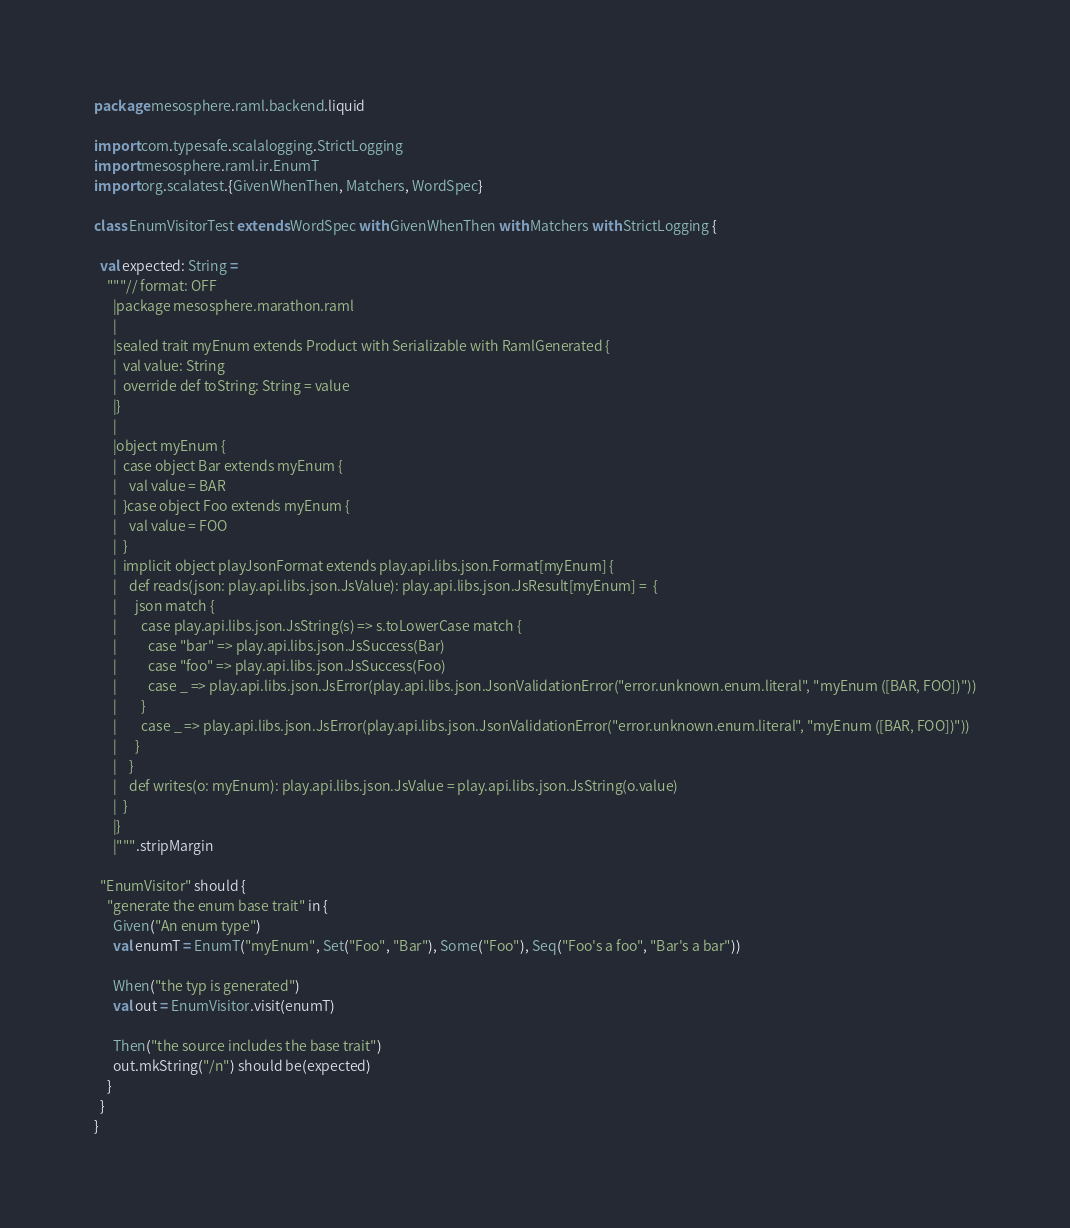Convert code to text. <code><loc_0><loc_0><loc_500><loc_500><_Scala_>package mesosphere.raml.backend.liquid

import com.typesafe.scalalogging.StrictLogging
import mesosphere.raml.ir.EnumT
import org.scalatest.{GivenWhenThen, Matchers, WordSpec}

class EnumVisitorTest extends WordSpec with GivenWhenThen with Matchers with StrictLogging {

  val expected: String =
    """// format: OFF
      |package mesosphere.marathon.raml
      |
      |sealed trait myEnum extends Product with Serializable with RamlGenerated {
      |  val value: String
      |  override def toString: String = value
      |}
      |
      |object myEnum {
      |  case object Bar extends myEnum {
      |    val value = BAR
      |  }case object Foo extends myEnum {
      |    val value = FOO
      |  }
      |  implicit object playJsonFormat extends play.api.libs.json.Format[myEnum] {
      |    def reads(json: play.api.libs.json.JsValue): play.api.libs.json.JsResult[myEnum] =  {
      |      json match {
      |        case play.api.libs.json.JsString(s) => s.toLowerCase match {
      |          case "bar" => play.api.libs.json.JsSuccess(Bar)
      |          case "foo" => play.api.libs.json.JsSuccess(Foo)
      |          case _ => play.api.libs.json.JsError(play.api.libs.json.JsonValidationError("error.unknown.enum.literal", "myEnum ([BAR, FOO])"))
      |        }
      |        case _ => play.api.libs.json.JsError(play.api.libs.json.JsonValidationError("error.unknown.enum.literal", "myEnum ([BAR, FOO])"))
      |      }
      |    }
      |    def writes(o: myEnum): play.api.libs.json.JsValue = play.api.libs.json.JsString(o.value)
      |  }
      |}
      |""".stripMargin

  "EnumVisitor" should {
    "generate the enum base trait" in {
      Given("An enum type")
      val enumT = EnumT("myEnum", Set("Foo", "Bar"), Some("Foo"), Seq("Foo's a foo", "Bar's a bar"))

      When("the typ is generated")
      val out = EnumVisitor.visit(enumT)

      Then("the source includes the base trait")
      out.mkString("/n") should be(expected)
    }
  }
}
</code> 